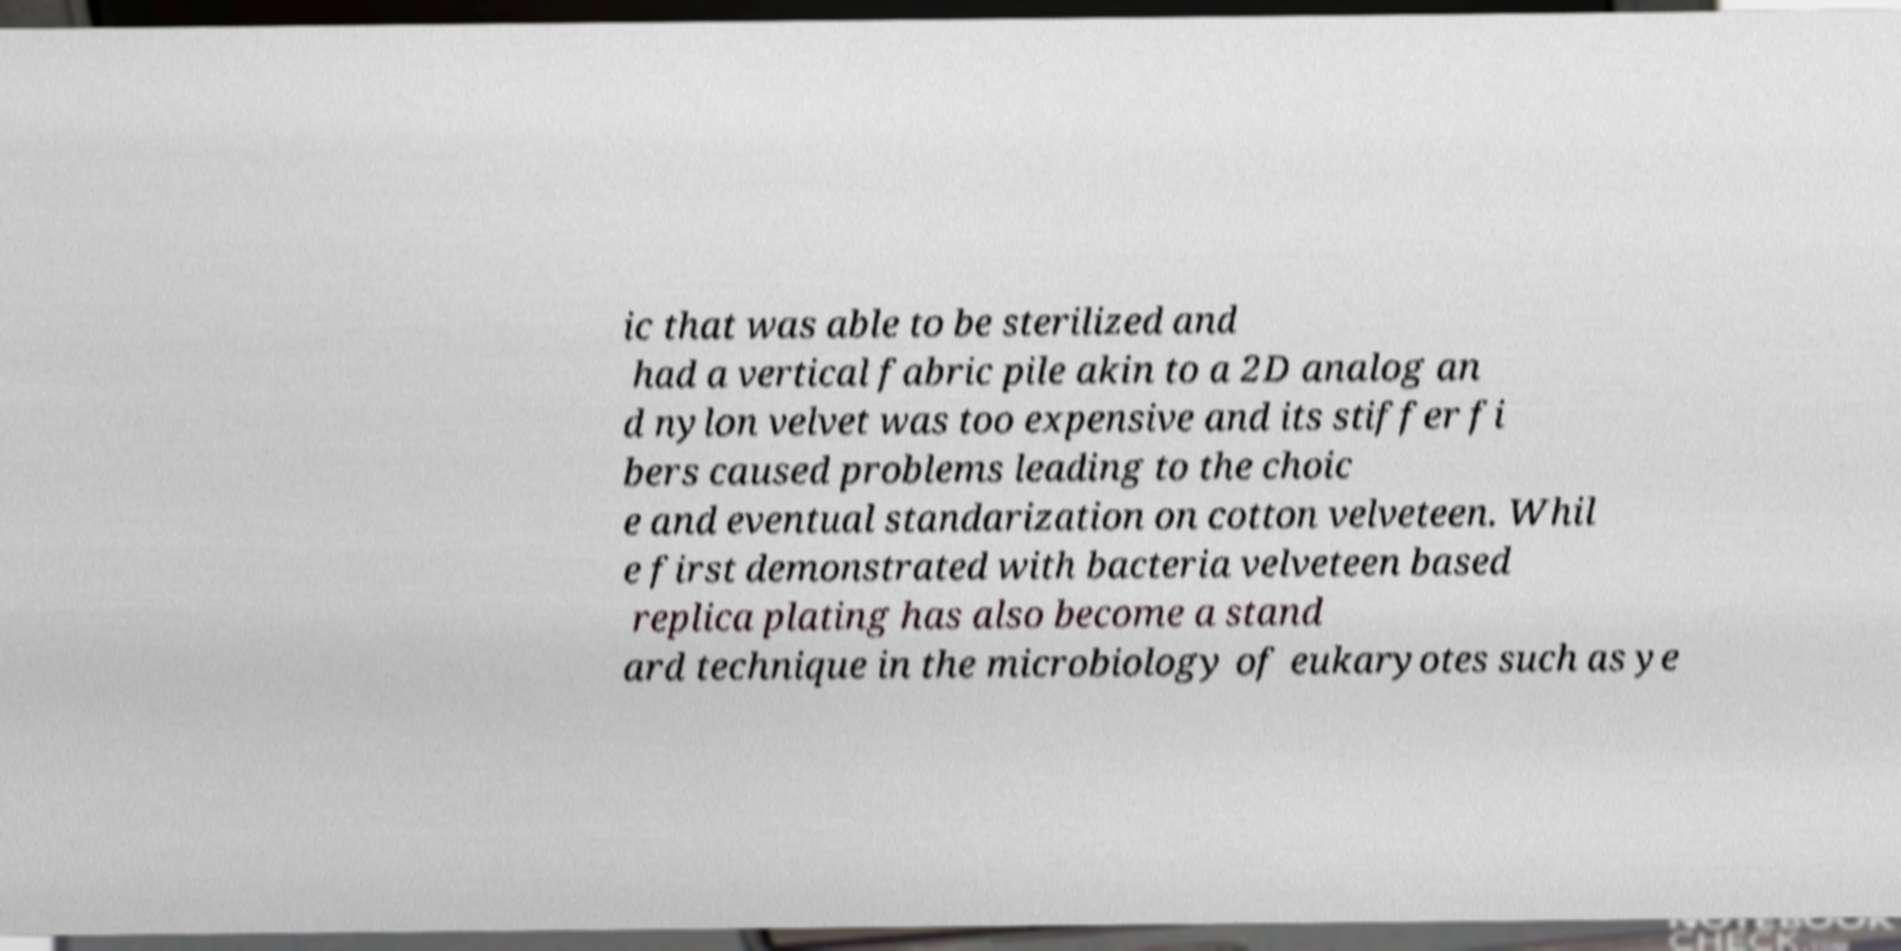Could you extract and type out the text from this image? ic that was able to be sterilized and had a vertical fabric pile akin to a 2D analog an d nylon velvet was too expensive and its stiffer fi bers caused problems leading to the choic e and eventual standarization on cotton velveteen. Whil e first demonstrated with bacteria velveteen based replica plating has also become a stand ard technique in the microbiology of eukaryotes such as ye 